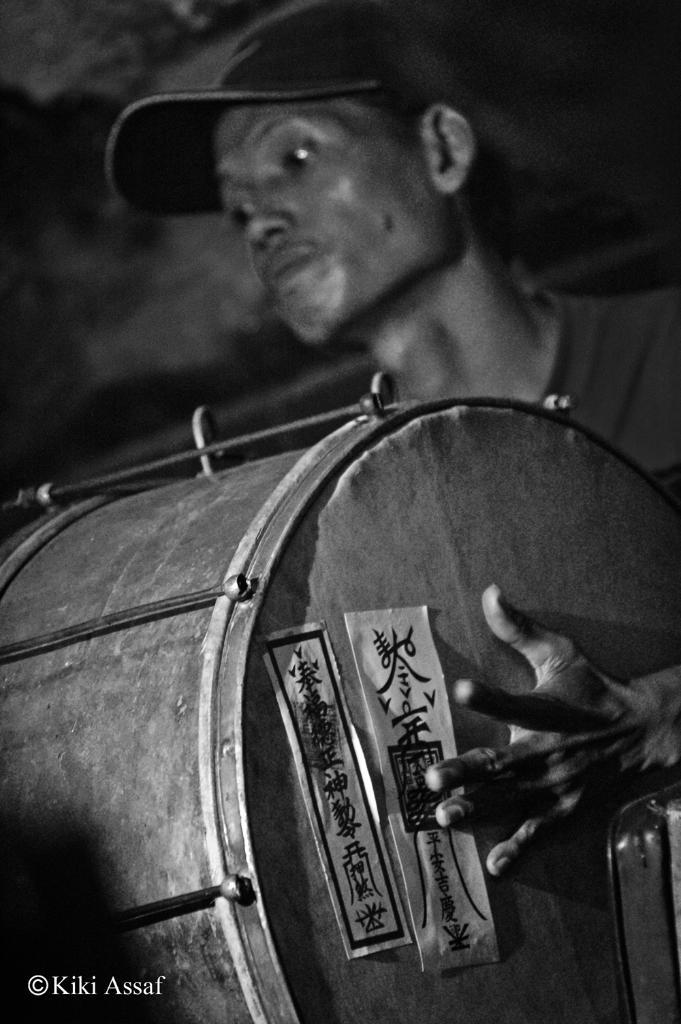Who is the main subject in the image? There is a man in the image. What is the man wearing on his head? The man is wearing a cap. What is the man doing in the image? The man is playing a drum with his hands. How many chairs are visible in the image? There are no chairs present in the image; it features a man playing a drum with his hands. What type of iron is being used by the man in the image? There is no iron present in the image; the man is playing a drum with his hands. 